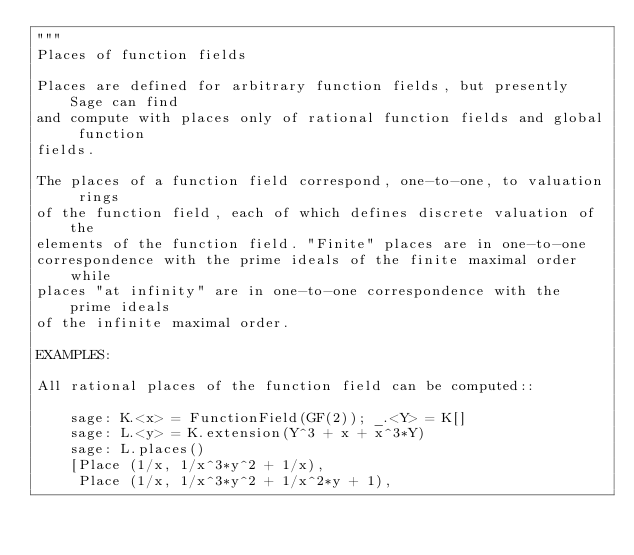<code> <loc_0><loc_0><loc_500><loc_500><_Python_>"""
Places of function fields

Places are defined for arbitrary function fields, but presently Sage can find
and compute with places only of rational function fields and global function
fields.

The places of a function field correspond, one-to-one, to valuation rings
of the function field, each of which defines discrete valuation of the
elements of the function field. "Finite" places are in one-to-one
correspondence with the prime ideals of the finite maximal order while
places "at infinity" are in one-to-one correspondence with the prime ideals
of the infinite maximal order.

EXAMPLES:

All rational places of the function field can be computed::

    sage: K.<x> = FunctionField(GF(2)); _.<Y> = K[]
    sage: L.<y> = K.extension(Y^3 + x + x^3*Y)
    sage: L.places()
    [Place (1/x, 1/x^3*y^2 + 1/x),
     Place (1/x, 1/x^3*y^2 + 1/x^2*y + 1),</code> 